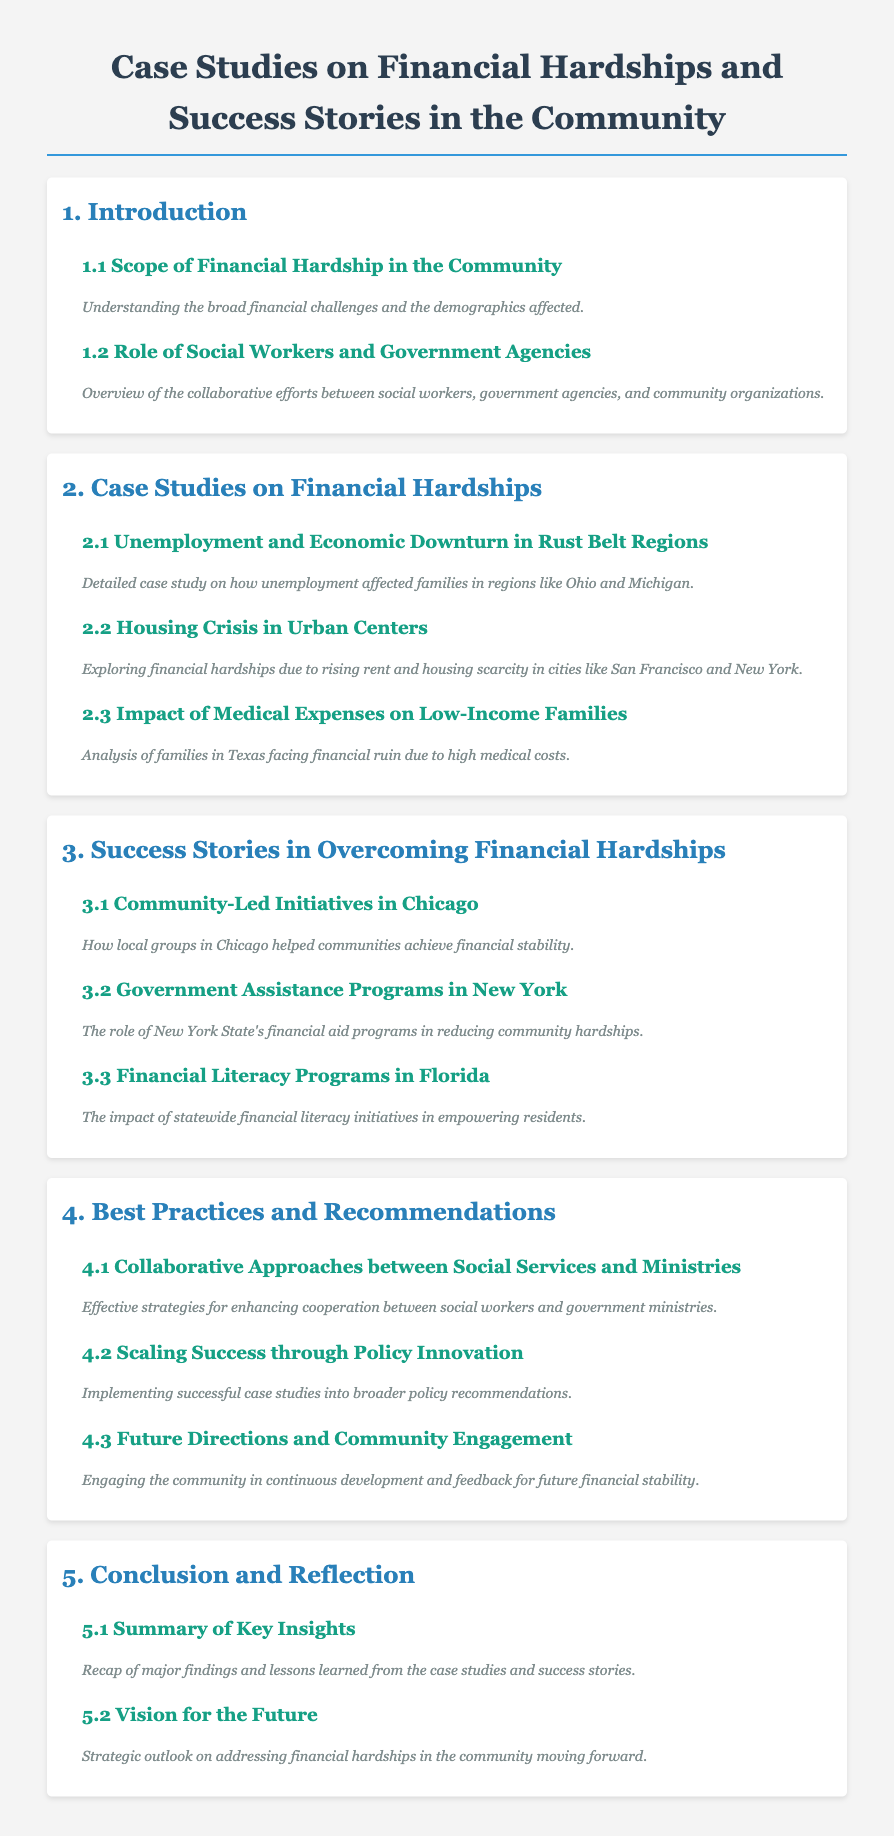what is the title of the document? The title of the document is presented in the main heading at the top.
Answer: Case Studies on Financial Hardships and Success Stories in the Community how many case studies focus on financial hardships? The number of case studies focusing on financial hardships is found in the second chapter, which lists three case studies.
Answer: 3 which urban centers are mentioned in the housing crisis case study? The specific urban centers mentioned in the housing crisis section can be found in the description of the related case study.
Answer: San Francisco and New York what is the focus of section 4.2? The focus of section 4.2 is indicated in the title of that section, which describes its main theme.
Answer: Scaling Success through Policy Innovation which community-led initiative is highlighted in Chicago? The specific initiative is referenced in the title of the related success story section.
Answer: Community-Led Initiatives in Chicago what demographic aspect does the introduction cover? This aspect is discussed within the context provided in section 1.1 of the document.
Answer: Scope of Financial Hardship in the Community what is the last section title in the document? The last section title can be found in the last chapter of the document.
Answer: Vision for the Future how many chapters does the document contain? The total number of chapters can be easily counted from the main headings listed in the table of contents.
Answer: 5 